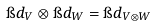Convert formula to latex. <formula><loc_0><loc_0><loc_500><loc_500>\i d _ { V } \otimes \i d _ { W } = \i d _ { V \otimes W }</formula> 